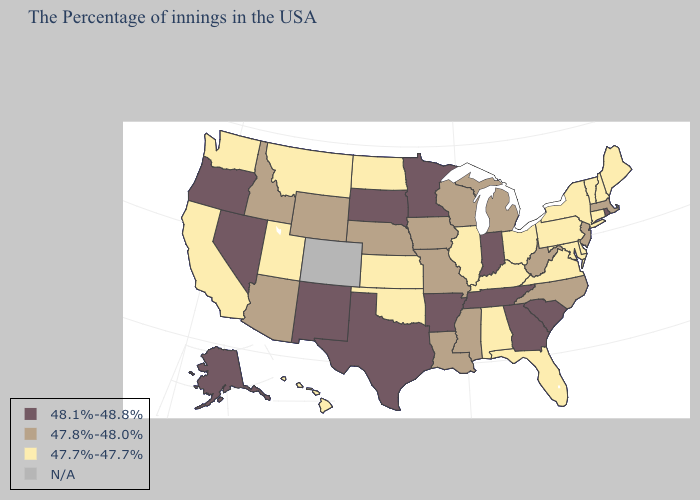What is the lowest value in the MidWest?
Quick response, please. 47.7%-47.7%. What is the highest value in the Northeast ?
Give a very brief answer. 48.1%-48.8%. What is the value of Indiana?
Short answer required. 48.1%-48.8%. Name the states that have a value in the range N/A?
Give a very brief answer. Colorado. What is the lowest value in the Northeast?
Keep it brief. 47.7%-47.7%. Which states hav the highest value in the Northeast?
Answer briefly. Rhode Island. What is the value of New Mexico?
Be succinct. 48.1%-48.8%. Which states have the highest value in the USA?
Be succinct. Rhode Island, South Carolina, Georgia, Indiana, Tennessee, Arkansas, Minnesota, Texas, South Dakota, New Mexico, Nevada, Oregon, Alaska. Name the states that have a value in the range 48.1%-48.8%?
Write a very short answer. Rhode Island, South Carolina, Georgia, Indiana, Tennessee, Arkansas, Minnesota, Texas, South Dakota, New Mexico, Nevada, Oregon, Alaska. How many symbols are there in the legend?
Short answer required. 4. Name the states that have a value in the range 47.8%-48.0%?
Short answer required. Massachusetts, New Jersey, North Carolina, West Virginia, Michigan, Wisconsin, Mississippi, Louisiana, Missouri, Iowa, Nebraska, Wyoming, Arizona, Idaho. Name the states that have a value in the range N/A?
Concise answer only. Colorado. Does Idaho have the highest value in the USA?
Keep it brief. No. Among the states that border South Carolina , which have the lowest value?
Concise answer only. North Carolina. 